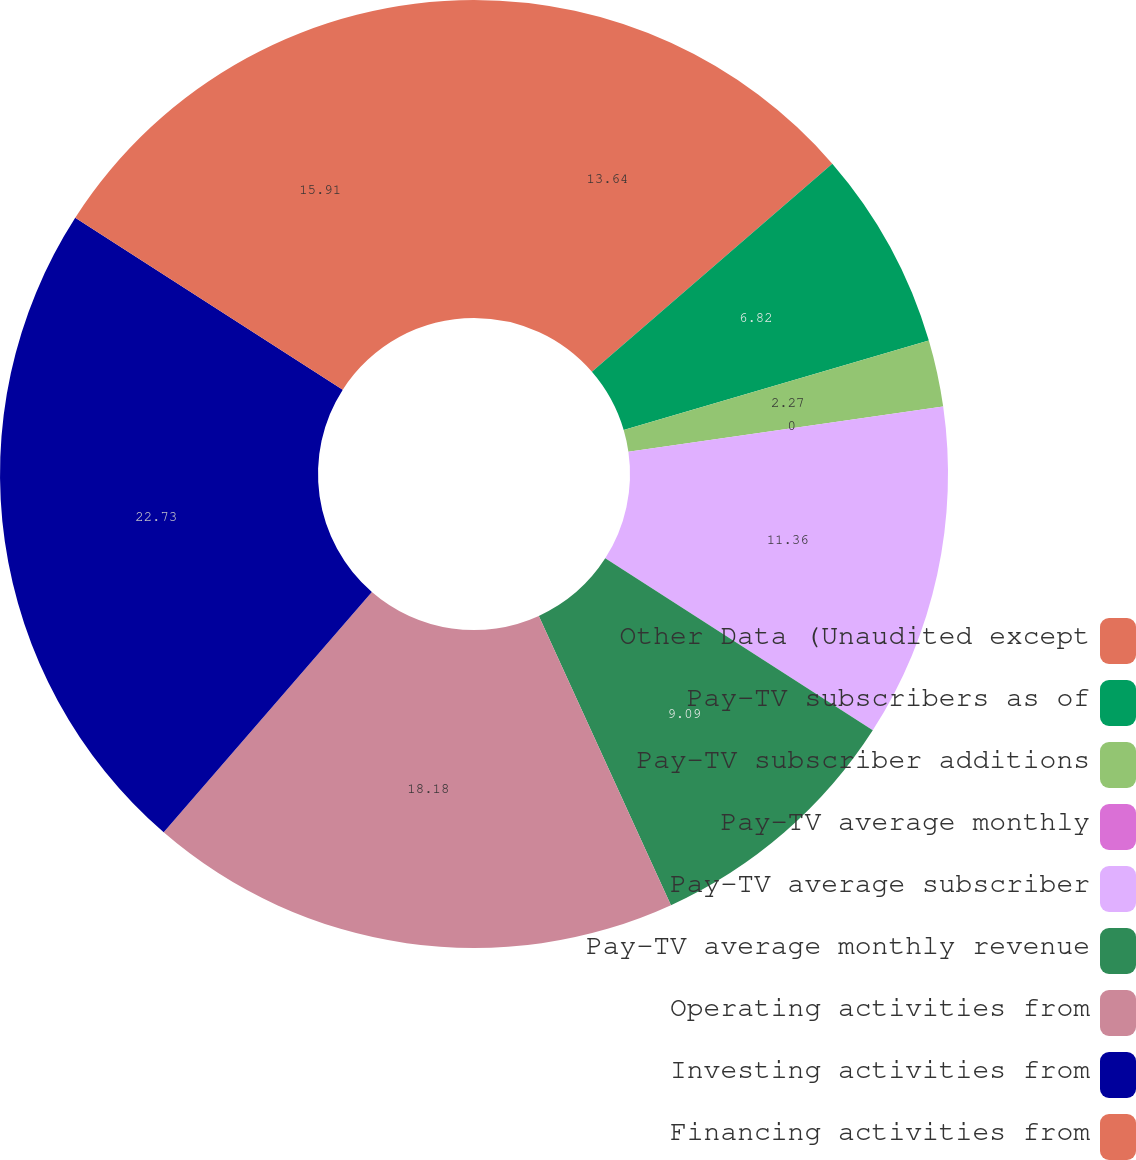Convert chart. <chart><loc_0><loc_0><loc_500><loc_500><pie_chart><fcel>Other Data (Unaudited except<fcel>Pay-TV subscribers as of<fcel>Pay-TV subscriber additions<fcel>Pay-TV average monthly<fcel>Pay-TV average subscriber<fcel>Pay-TV average monthly revenue<fcel>Operating activities from<fcel>Investing activities from<fcel>Financing activities from<nl><fcel>13.64%<fcel>6.82%<fcel>2.27%<fcel>0.0%<fcel>11.36%<fcel>9.09%<fcel>18.18%<fcel>22.73%<fcel>15.91%<nl></chart> 